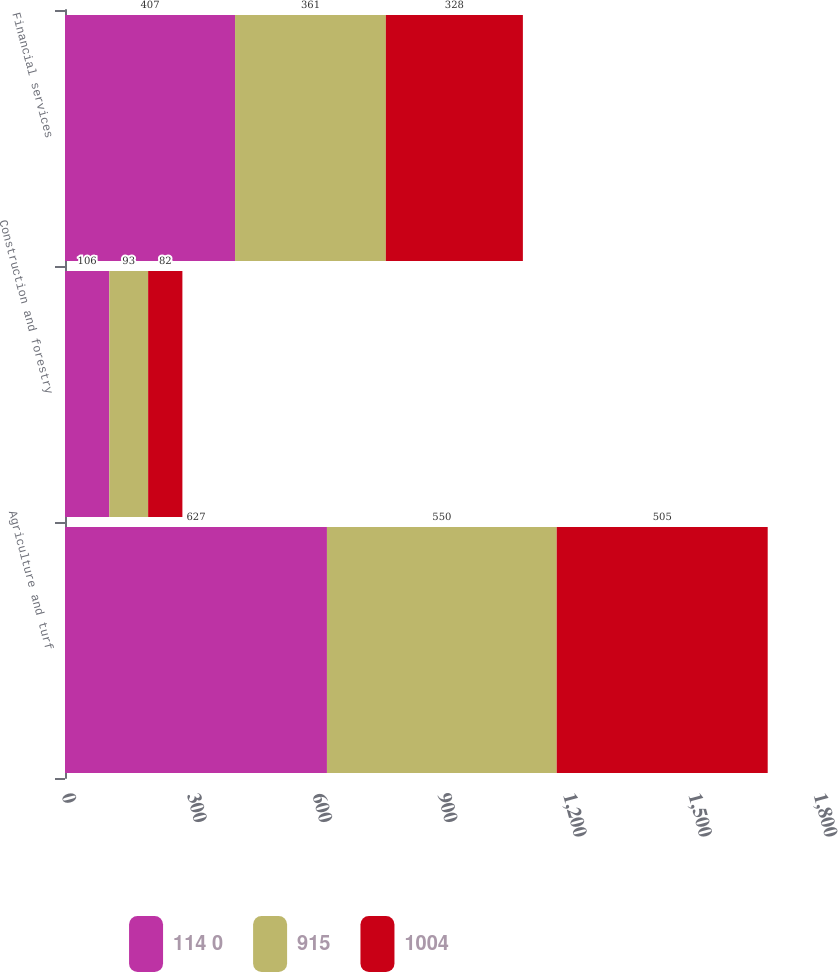Convert chart to OTSL. <chart><loc_0><loc_0><loc_500><loc_500><stacked_bar_chart><ecel><fcel>Agriculture and turf<fcel>Construction and forestry<fcel>Financial services<nl><fcel>114 0<fcel>627<fcel>106<fcel>407<nl><fcel>915<fcel>550<fcel>93<fcel>361<nl><fcel>1004<fcel>505<fcel>82<fcel>328<nl></chart> 